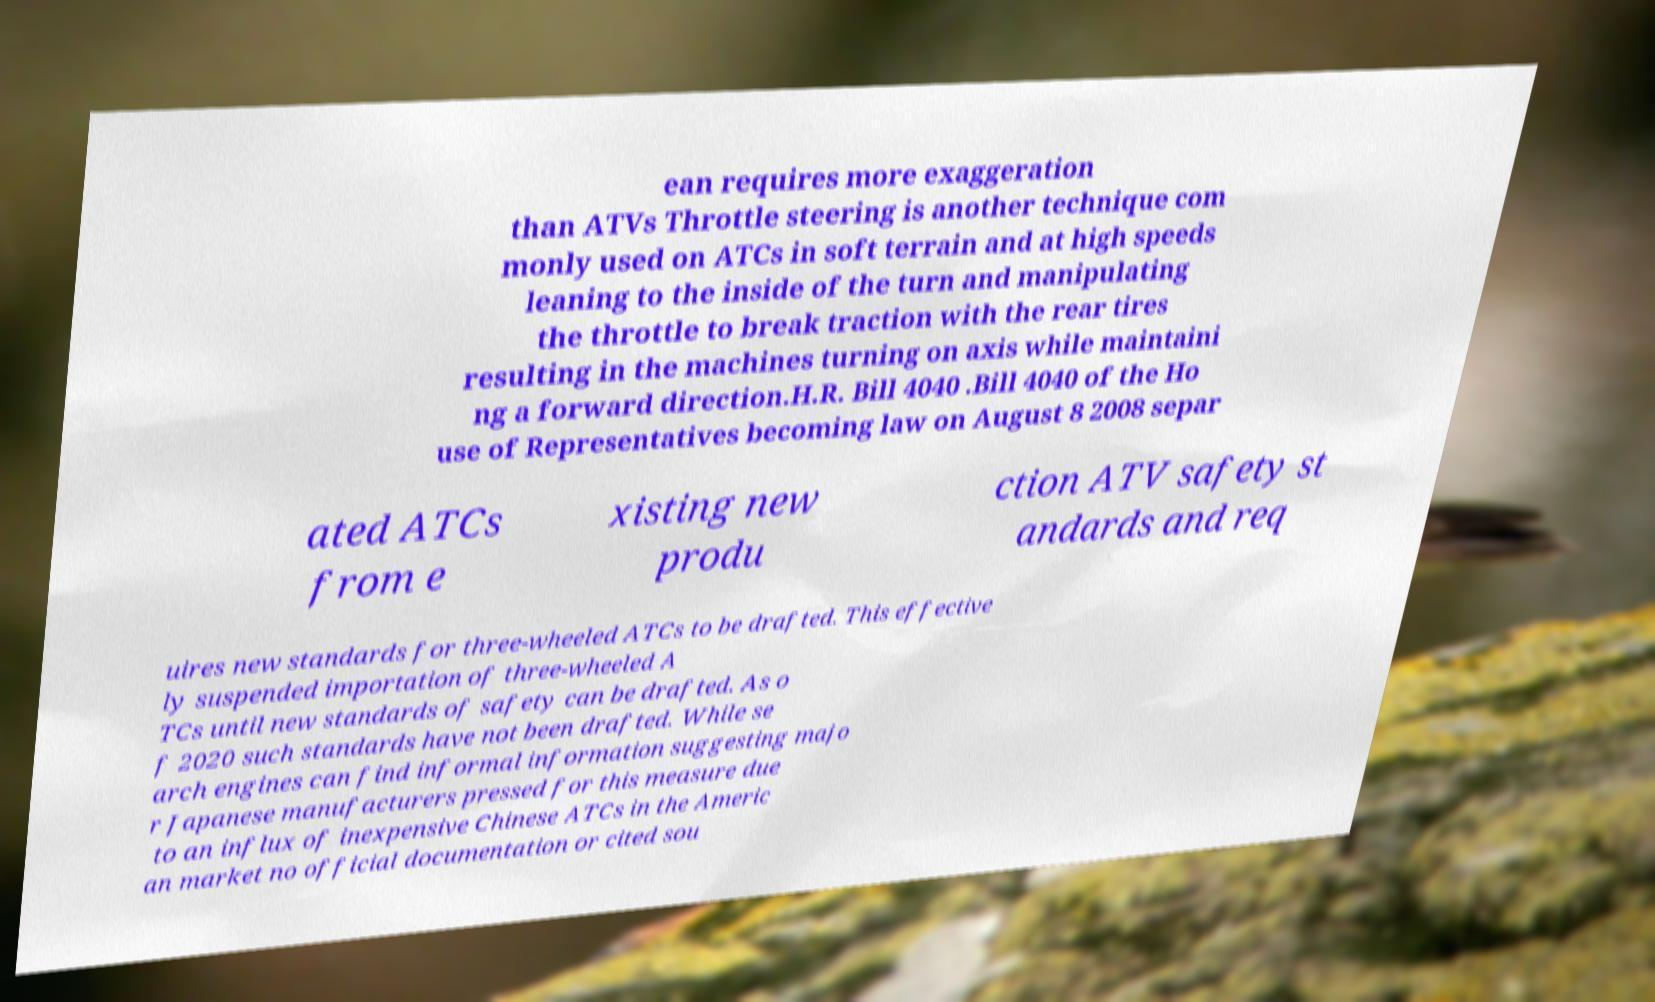Can you accurately transcribe the text from the provided image for me? ean requires more exaggeration than ATVs Throttle steering is another technique com monly used on ATCs in soft terrain and at high speeds leaning to the inside of the turn and manipulating the throttle to break traction with the rear tires resulting in the machines turning on axis while maintaini ng a forward direction.H.R. Bill 4040 .Bill 4040 of the Ho use of Representatives becoming law on August 8 2008 separ ated ATCs from e xisting new produ ction ATV safety st andards and req uires new standards for three-wheeled ATCs to be drafted. This effective ly suspended importation of three-wheeled A TCs until new standards of safety can be drafted. As o f 2020 such standards have not been drafted. While se arch engines can find informal information suggesting majo r Japanese manufacturers pressed for this measure due to an influx of inexpensive Chinese ATCs in the Americ an market no official documentation or cited sou 